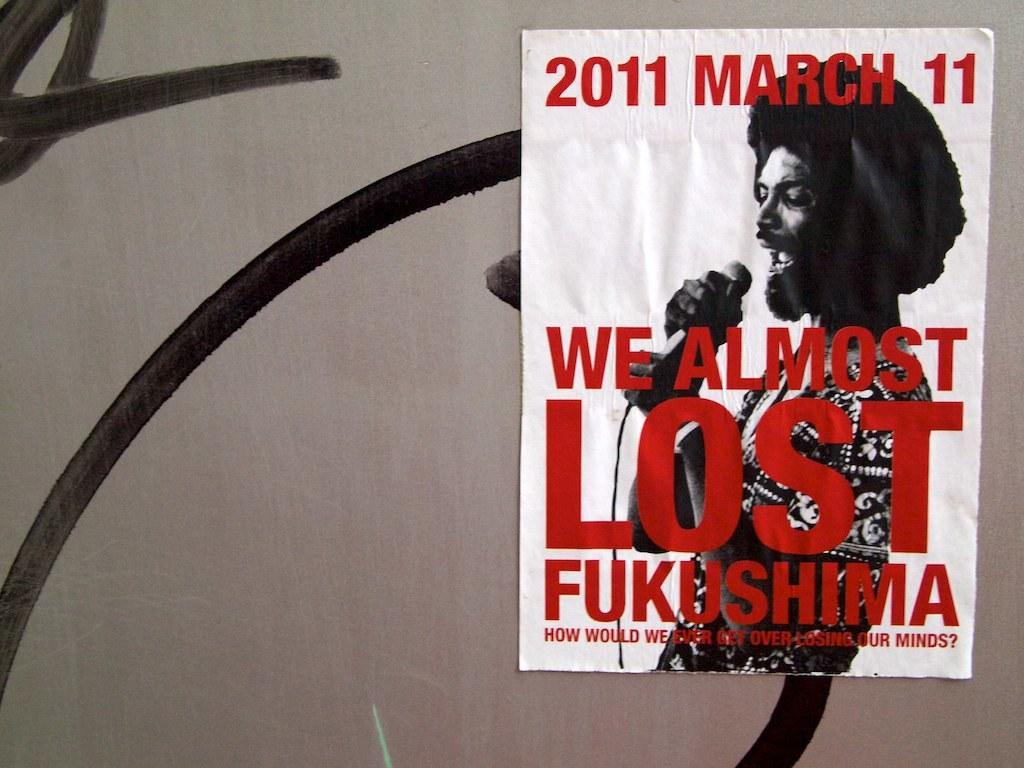<image>
Summarize the visual content of the image. A promotional poster advertising that We Almost Lost Fukushima. 